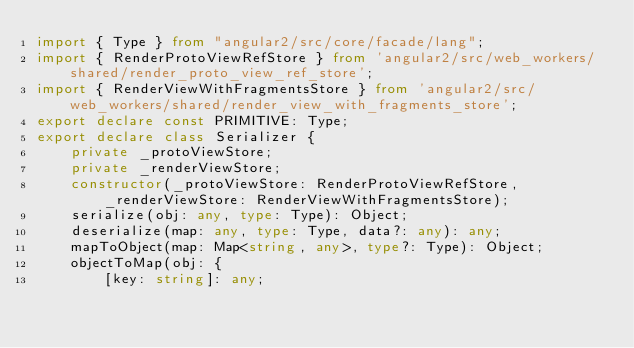Convert code to text. <code><loc_0><loc_0><loc_500><loc_500><_TypeScript_>import { Type } from "angular2/src/core/facade/lang";
import { RenderProtoViewRefStore } from 'angular2/src/web_workers/shared/render_proto_view_ref_store';
import { RenderViewWithFragmentsStore } from 'angular2/src/web_workers/shared/render_view_with_fragments_store';
export declare const PRIMITIVE: Type;
export declare class Serializer {
    private _protoViewStore;
    private _renderViewStore;
    constructor(_protoViewStore: RenderProtoViewRefStore, _renderViewStore: RenderViewWithFragmentsStore);
    serialize(obj: any, type: Type): Object;
    deserialize(map: any, type: Type, data?: any): any;
    mapToObject(map: Map<string, any>, type?: Type): Object;
    objectToMap(obj: {
        [key: string]: any;</code> 